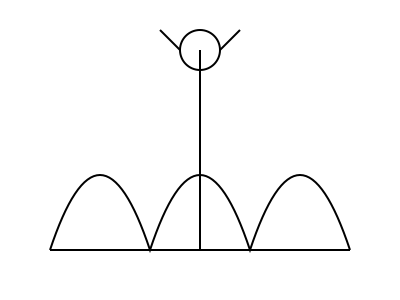Examine the simplified dinosaur skeleton diagram. Which modern animal group shares a similar spinal structure, and what does this suggest about the dinosaur's movement? 1. Observe the curved spine in the diagram, which forms an S-shape when viewed from the side.

2. This S-shaped spine is a characteristic feature of many theropod dinosaurs, including the ancestors of modern birds.

3. In modern animals, this spinal structure is most prominently seen in birds.

4. The S-shaped spine allows for:
   a) Improved balance and weight distribution
   b) More efficient locomotion
   c) Greater flexibility in the neck and tail regions

5. This spinal structure suggests that the dinosaur likely moved in a manner similar to modern birds, with:
   a) An upright posture
   b) Bipedal locomotion (walking on two legs)
   c) The ability to make quick, agile movements

6. The similarity between this dinosaur's spine and that of modern birds supports the theory of the evolutionary link between theropod dinosaurs and birds.

7. This connection aligns with ancestral knowledge of human-dinosaur interactions, as it suggests a continuity between ancient creatures and modern animals that we still observe today.
Answer: Birds; bipedal and agile movement 